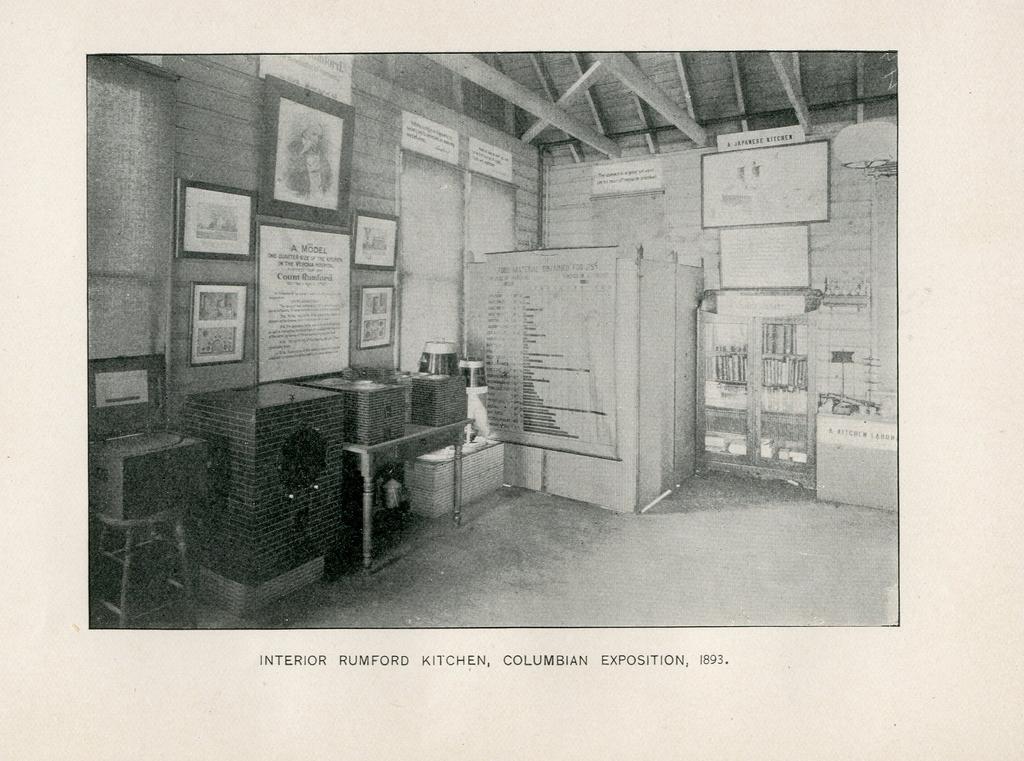Describe this image in one or two sentences. This image is a photograph. In this photo there are tables, chairs and wall frames placed on the wall. On the right there is a board and there is a shelf. 